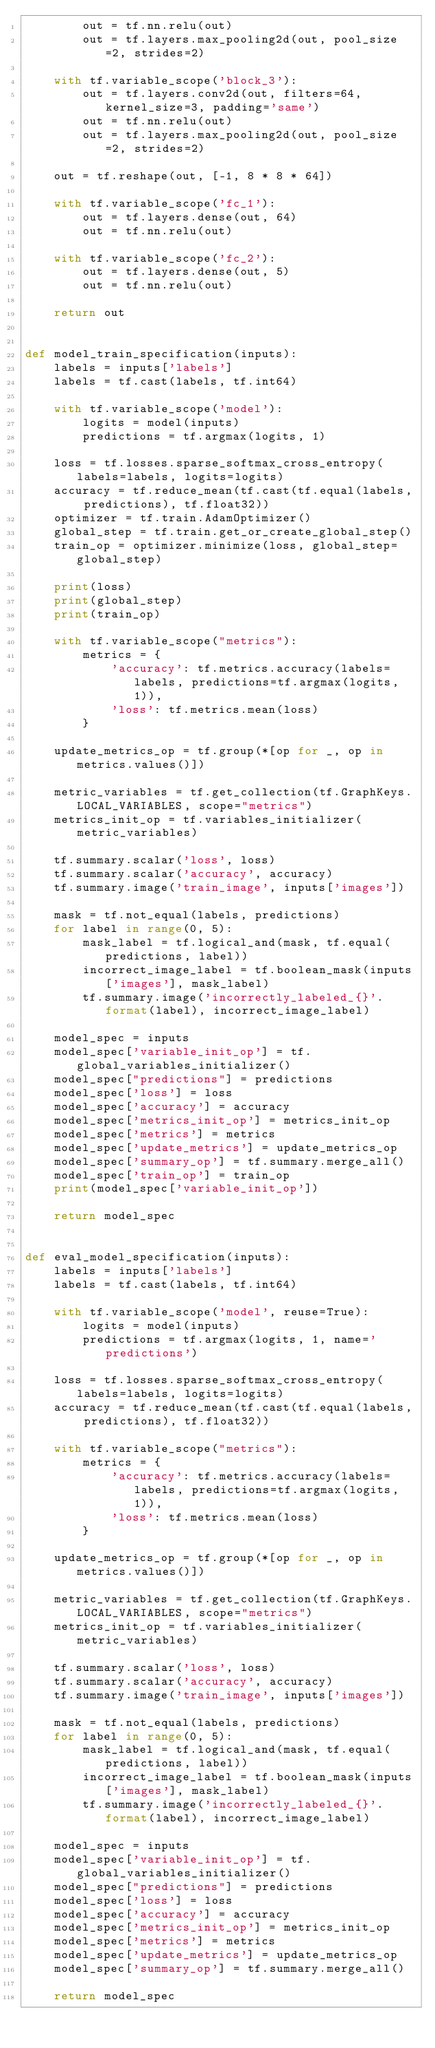<code> <loc_0><loc_0><loc_500><loc_500><_Python_>        out = tf.nn.relu(out)
        out = tf.layers.max_pooling2d(out, pool_size=2, strides=2)

    with tf.variable_scope('block_3'):
        out = tf.layers.conv2d(out, filters=64, kernel_size=3, padding='same')
        out = tf.nn.relu(out)
        out = tf.layers.max_pooling2d(out, pool_size=2, strides=2)

    out = tf.reshape(out, [-1, 8 * 8 * 64])

    with tf.variable_scope('fc_1'):
        out = tf.layers.dense(out, 64)
        out = tf.nn.relu(out)

    with tf.variable_scope('fc_2'):
        out = tf.layers.dense(out, 5)
        out = tf.nn.relu(out)

    return out


def model_train_specification(inputs):
    labels = inputs['labels']
    labels = tf.cast(labels, tf.int64)

    with tf.variable_scope('model'):
        logits = model(inputs)
        predictions = tf.argmax(logits, 1)

    loss = tf.losses.sparse_softmax_cross_entropy(labels=labels, logits=logits)
    accuracy = tf.reduce_mean(tf.cast(tf.equal(labels, predictions), tf.float32))
    optimizer = tf.train.AdamOptimizer()
    global_step = tf.train.get_or_create_global_step()
    train_op = optimizer.minimize(loss, global_step=global_step)

    print(loss)
    print(global_step)
    print(train_op)

    with tf.variable_scope("metrics"):
        metrics = {
            'accuracy': tf.metrics.accuracy(labels=labels, predictions=tf.argmax(logits, 1)),
            'loss': tf.metrics.mean(loss)
        }

    update_metrics_op = tf.group(*[op for _, op in metrics.values()])

    metric_variables = tf.get_collection(tf.GraphKeys.LOCAL_VARIABLES, scope="metrics")
    metrics_init_op = tf.variables_initializer(metric_variables)

    tf.summary.scalar('loss', loss)
    tf.summary.scalar('accuracy', accuracy)
    tf.summary.image('train_image', inputs['images'])

    mask = tf.not_equal(labels, predictions)
    for label in range(0, 5):
        mask_label = tf.logical_and(mask, tf.equal(predictions, label))
        incorrect_image_label = tf.boolean_mask(inputs['images'], mask_label)
        tf.summary.image('incorrectly_labeled_{}'.format(label), incorrect_image_label)

    model_spec = inputs
    model_spec['variable_init_op'] = tf.global_variables_initializer()
    model_spec["predictions"] = predictions
    model_spec['loss'] = loss
    model_spec['accuracy'] = accuracy
    model_spec['metrics_init_op'] = metrics_init_op
    model_spec['metrics'] = metrics
    model_spec['update_metrics'] = update_metrics_op
    model_spec['summary_op'] = tf.summary.merge_all()
    model_spec['train_op'] = train_op
    print(model_spec['variable_init_op'])

    return model_spec


def eval_model_specification(inputs):
    labels = inputs['labels']
    labels = tf.cast(labels, tf.int64)

    with tf.variable_scope('model', reuse=True):
        logits = model(inputs)
        predictions = tf.argmax(logits, 1, name='predictions')

    loss = tf.losses.sparse_softmax_cross_entropy(labels=labels, logits=logits)
    accuracy = tf.reduce_mean(tf.cast(tf.equal(labels, predictions), tf.float32))

    with tf.variable_scope("metrics"):
        metrics = {
            'accuracy': tf.metrics.accuracy(labels=labels, predictions=tf.argmax(logits, 1)),
            'loss': tf.metrics.mean(loss)
        }

    update_metrics_op = tf.group(*[op for _, op in metrics.values()])

    metric_variables = tf.get_collection(tf.GraphKeys.LOCAL_VARIABLES, scope="metrics")
    metrics_init_op = tf.variables_initializer(metric_variables)

    tf.summary.scalar('loss', loss)
    tf.summary.scalar('accuracy', accuracy)
    tf.summary.image('train_image', inputs['images'])

    mask = tf.not_equal(labels, predictions)
    for label in range(0, 5):
        mask_label = tf.logical_and(mask, tf.equal(predictions, label))
        incorrect_image_label = tf.boolean_mask(inputs['images'], mask_label)
        tf.summary.image('incorrectly_labeled_{}'.format(label), incorrect_image_label)

    model_spec = inputs
    model_spec['variable_init_op'] = tf.global_variables_initializer()
    model_spec["predictions"] = predictions
    model_spec['loss'] = loss
    model_spec['accuracy'] = accuracy
    model_spec['metrics_init_op'] = metrics_init_op
    model_spec['metrics'] = metrics
    model_spec['update_metrics'] = update_metrics_op
    model_spec['summary_op'] = tf.summary.merge_all()

    return model_spec</code> 